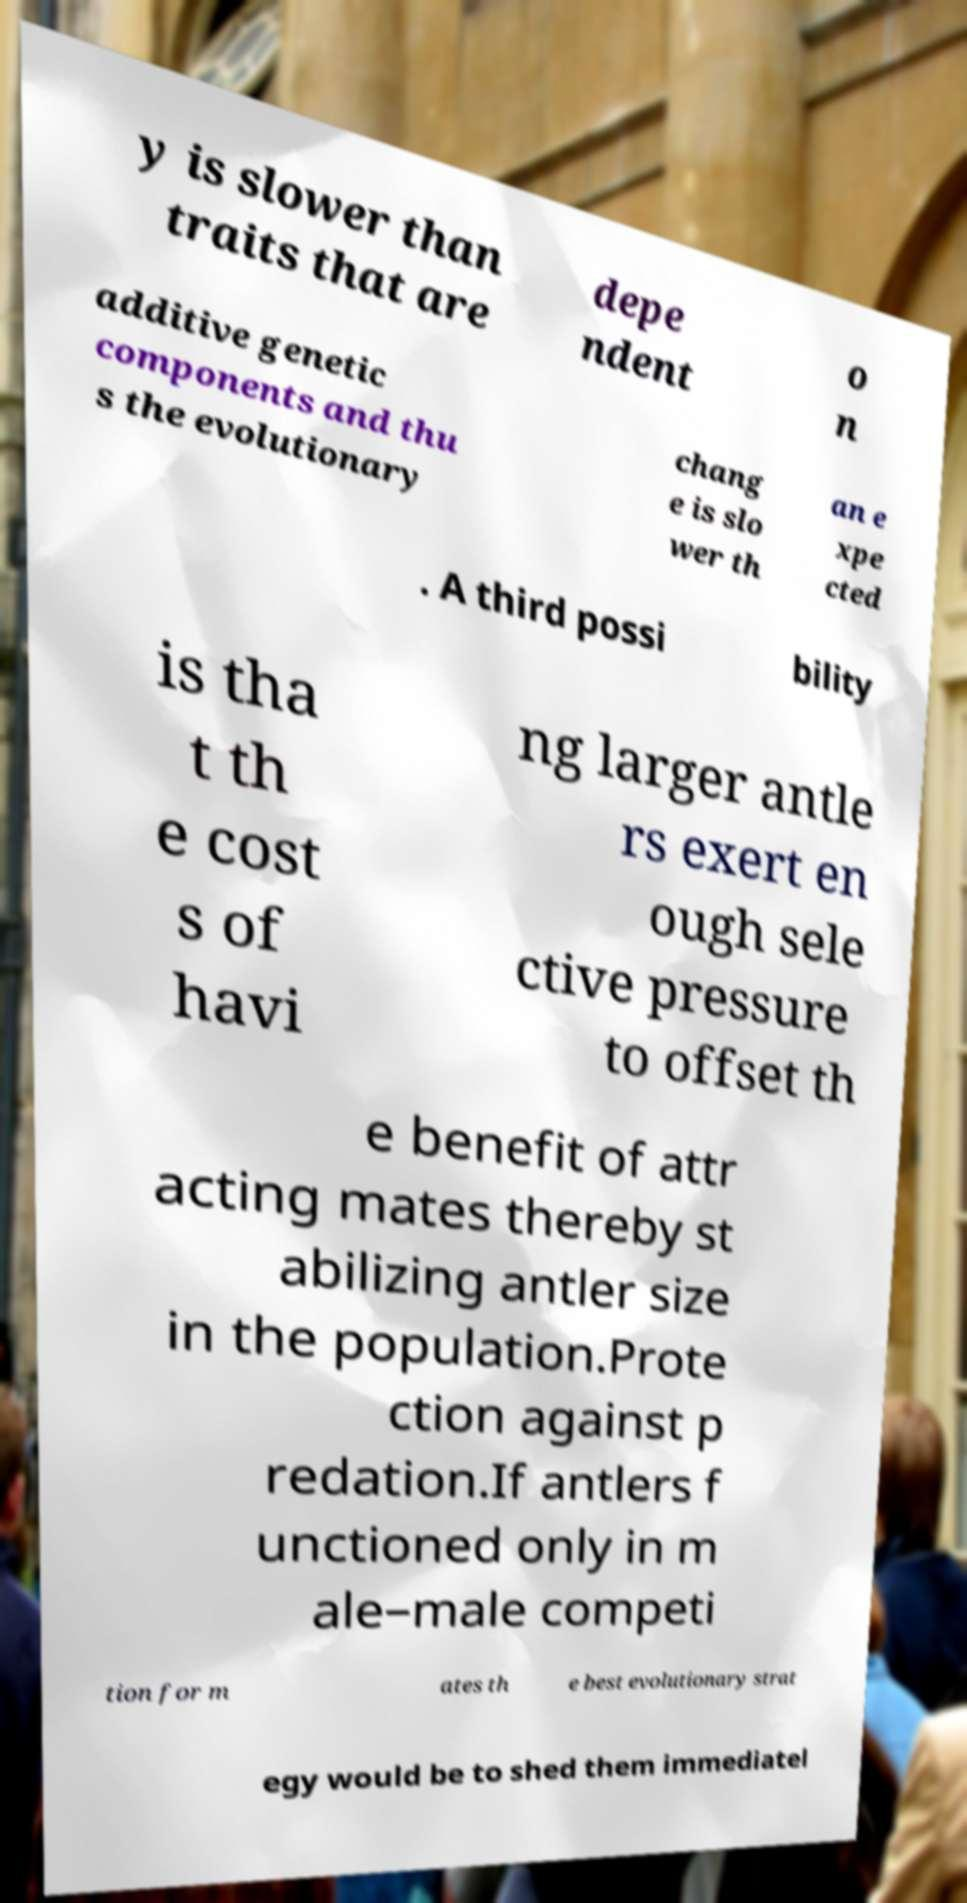What messages or text are displayed in this image? I need them in a readable, typed format. y is slower than traits that are depe ndent o n additive genetic components and thu s the evolutionary chang e is slo wer th an e xpe cted . A third possi bility is tha t th e cost s of havi ng larger antle rs exert en ough sele ctive pressure to offset th e benefit of attr acting mates thereby st abilizing antler size in the population.Prote ction against p redation.If antlers f unctioned only in m ale–male competi tion for m ates th e best evolutionary strat egy would be to shed them immediatel 